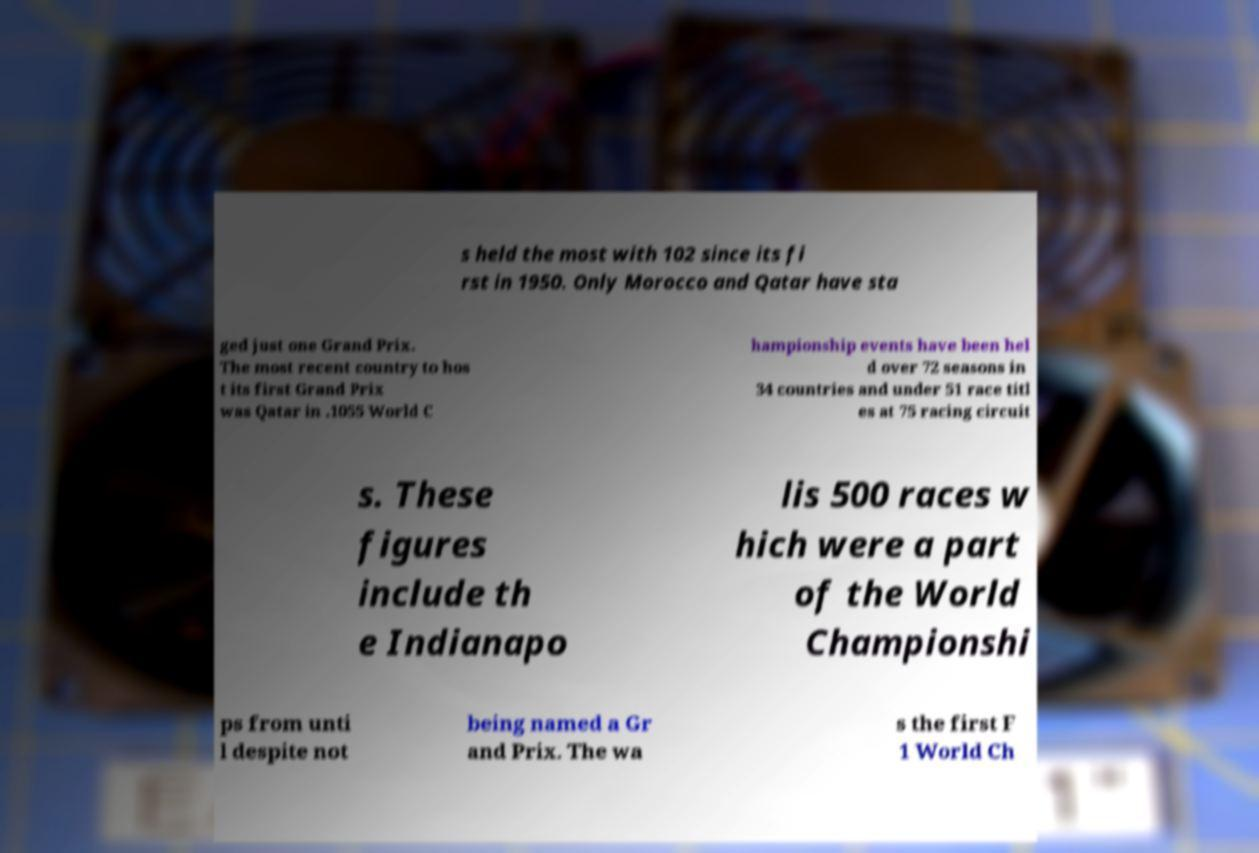For documentation purposes, I need the text within this image transcribed. Could you provide that? s held the most with 102 since its fi rst in 1950. Only Morocco and Qatar have sta ged just one Grand Prix. The most recent country to hos t its first Grand Prix was Qatar in .1055 World C hampionship events have been hel d over 72 seasons in 34 countries and under 51 race titl es at 75 racing circuit s. These figures include th e Indianapo lis 500 races w hich were a part of the World Championshi ps from unti l despite not being named a Gr and Prix. The wa s the first F 1 World Ch 